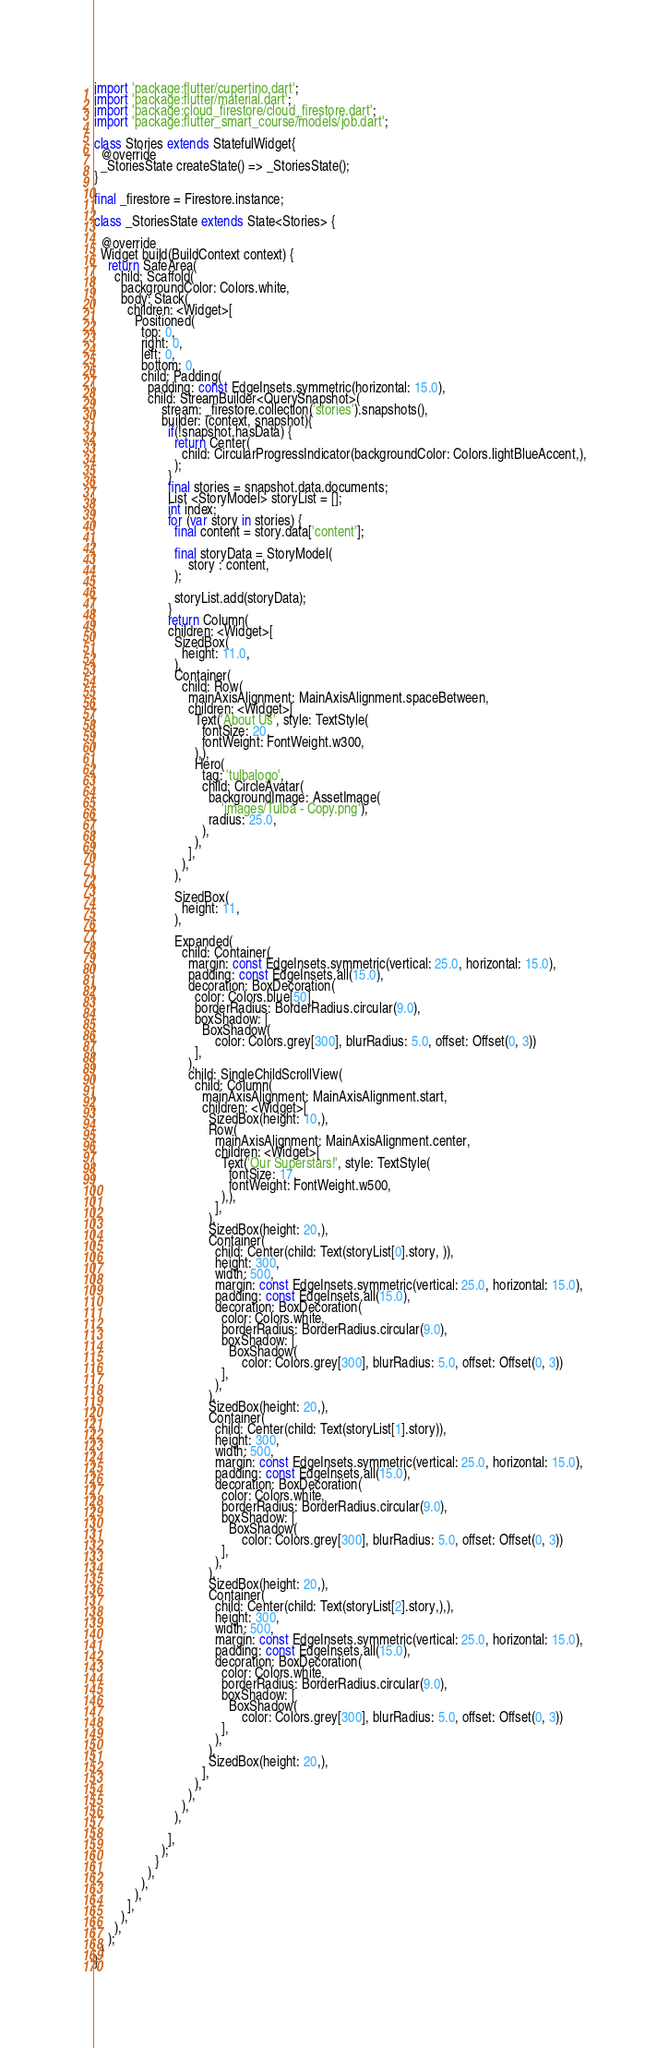<code> <loc_0><loc_0><loc_500><loc_500><_Dart_>import 'package:flutter/cupertino.dart';
import 'package:flutter/material.dart';
import 'package:cloud_firestore/cloud_firestore.dart';
import 'package:flutter_smart_course/models/job.dart';

class Stories extends StatefulWidget{
  @override
  _StoriesState createState() => _StoriesState();
}

final _firestore = Firestore.instance;

class _StoriesState extends State<Stories> {

  @override
  Widget build(BuildContext context) {
    return SafeArea(
      child: Scaffold(
        backgroundColor: Colors.white,
        body: Stack(
          children: <Widget>[
            Positioned(
              top: 0,
              right: 0,
              left: 0,
              bottom: 0,
              child: Padding(
                padding: const EdgeInsets.symmetric(horizontal: 15.0),
                child: StreamBuilder<QuerySnapshot>(
                    stream: _firestore.collection('stories').snapshots(),
                    builder: (context, snapshot){
                      if(!snapshot.hasData) {
                        return Center(
                          child: CircularProgressIndicator(backgroundColor: Colors.lightBlueAccent,),
                        );
                      }
                      final stories = snapshot.data.documents;
                      List <StoryModel> storyList = [];
                      int index;
                      for (var story in stories) {
                        final content = story.data['content'];

                        final storyData = StoryModel(
                            story : content,
                        );

                        storyList.add(storyData);
                      }
                      return Column(
                      children: <Widget>[
                        SizedBox(
                          height: 11.0,
                        ),
                        Container(
                          child: Row(
                            mainAxisAlignment: MainAxisAlignment.spaceBetween,
                            children: <Widget>[
                              Text('About Us', style: TextStyle(
                                fontSize: 20,
                                fontWeight: FontWeight.w300,
                              ),),
                              Hero(
                                tag: 'tulbalogo',
                                child: CircleAvatar(
                                  backgroundImage: AssetImage(
                                      'images/Tulba - Copy.png'),
                                  radius: 25.0,
                                ),
                              ),
                            ],
                          ),
                        ),

                        SizedBox(
                          height: 11,
                        ),

                        Expanded(
                          child: Container(
                            margin: const EdgeInsets.symmetric(vertical: 25.0, horizontal: 15.0),
                            padding: const EdgeInsets.all(15.0),
                            decoration: BoxDecoration(
                              color: Colors.blue[50],
                              borderRadius: BorderRadius.circular(9.0),
                              boxShadow: [
                                BoxShadow(
                                    color: Colors.grey[300], blurRadius: 5.0, offset: Offset(0, 3))
                              ],
                            ),
                            child: SingleChildScrollView(
                              child: Column(
                                mainAxisAlignment: MainAxisAlignment.start,
                                children: <Widget>[
                                  SizedBox(height: 10,),
                                  Row(
                                    mainAxisAlignment: MainAxisAlignment.center,
                                    children: <Widget>[
                                      Text('Our Superstars!', style: TextStyle(
                                        fontSize: 17,
                                        fontWeight: FontWeight.w500,
                                      ),),
                                    ],
                                  ),
                                  SizedBox(height: 20,),
                                  Container(
                                    child: Center(child: Text(storyList[0].story, )),
                                    height: 300,
                                    width: 500,
                                    margin: const EdgeInsets.symmetric(vertical: 25.0, horizontal: 15.0),
                                    padding: const EdgeInsets.all(15.0),
                                    decoration: BoxDecoration(
                                      color: Colors.white,
                                      borderRadius: BorderRadius.circular(9.0),
                                      boxShadow: [
                                        BoxShadow(
                                            color: Colors.grey[300], blurRadius: 5.0, offset: Offset(0, 3))
                                      ],
                                    ),
                                  ),
                                  SizedBox(height: 20,),
                                  Container(
                                    child: Center(child: Text(storyList[1].story)),
                                    height: 300,
                                    width: 500,
                                    margin: const EdgeInsets.symmetric(vertical: 25.0, horizontal: 15.0),
                                    padding: const EdgeInsets.all(15.0),
                                    decoration: BoxDecoration(
                                      color: Colors.white,
                                      borderRadius: BorderRadius.circular(9.0),
                                      boxShadow: [
                                        BoxShadow(
                                            color: Colors.grey[300], blurRadius: 5.0, offset: Offset(0, 3))
                                      ],
                                    ),
                                  ),
                                  SizedBox(height: 20,),
                                  Container(
                                    child: Center(child: Text(storyList[2].story,),),
                                    height: 300,
                                    width: 500,
                                    margin: const EdgeInsets.symmetric(vertical: 25.0, horizontal: 15.0),
                                    padding: const EdgeInsets.all(15.0),
                                    decoration: BoxDecoration(
                                      color: Colors.white,
                                      borderRadius: BorderRadius.circular(9.0),
                                      boxShadow: [
                                        BoxShadow(
                                            color: Colors.grey[300], blurRadius: 5.0, offset: Offset(0, 3))
                                      ],
                                    ),
                                  ),
                                  SizedBox(height: 20,),
                                ],
                              ),
                            ),
                          ),
                        ),

                      ],
                    );
                  }
                ),
              ),
            ),
          ],
        ),
      ),
    );
  }
}
</code> 